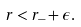<formula> <loc_0><loc_0><loc_500><loc_500>r < r _ { - } + \epsilon .</formula> 